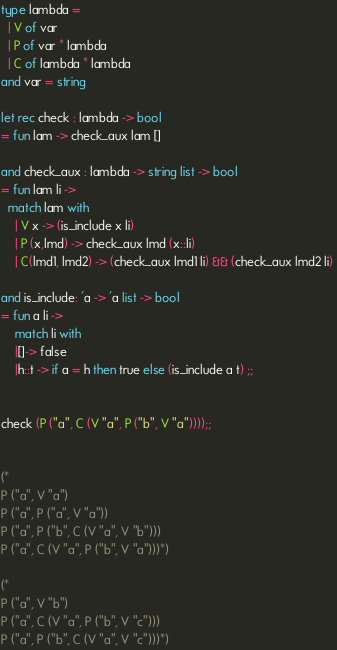<code> <loc_0><loc_0><loc_500><loc_500><_OCaml_>type lambda = 
  | V of var
  | P of var * lambda
  | C of lambda * lambda
and var = string

let rec check : lambda -> bool
= fun lam -> check_aux lam []

and check_aux : lambda -> string list -> bool
= fun lam li ->
  match lam with
    | V x -> (is_include x li)
    | P (x,lmd) -> check_aux lmd (x::li) 
    | C(lmd1, lmd2) -> (check_aux lmd1 li) && (check_aux lmd2 li) 
      
and is_include: 'a -> 'a list -> bool
= fun a li ->
	match li with
	|[]-> false
	|h::t -> if a = h then true else (is_include a t) ;; 
	

check (P ("a", C (V "a", P ("b", V "a"))));;


(*
P ("a", V "a")
P ("a", P ("a", V "a"))
P ("a", P ("b", C (V "a", V "b")))
P ("a", C (V "a", P ("b", V "a")))*)

(*
P ("a", V "b")
P ("a", C (V "a", P ("b", V "c")))
P ("a", P ("b", C (V "a", V "c")))*)
</code> 